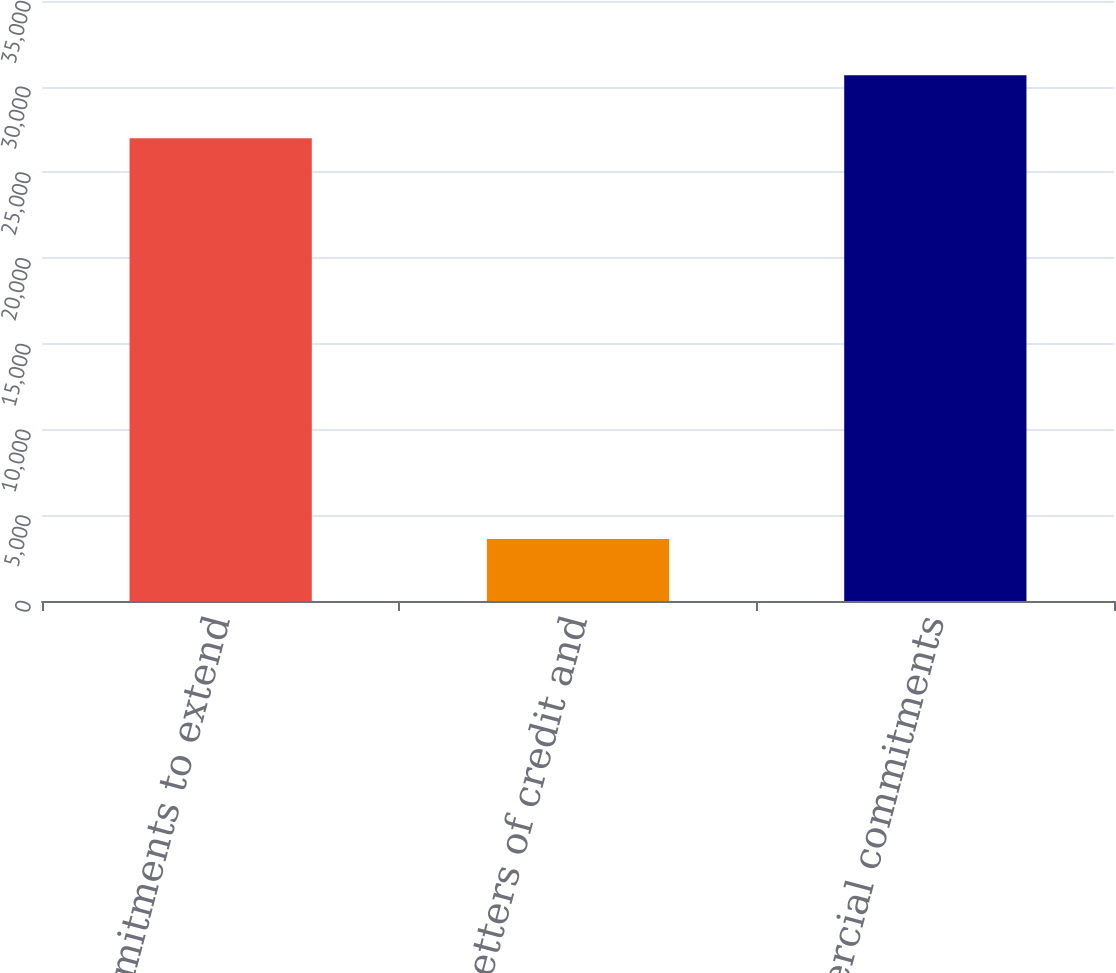Convert chart. <chart><loc_0><loc_0><loc_500><loc_500><bar_chart><fcel>Unused commitments to extend<fcel>Standby letters of credit and<fcel>Total commercial commitments<nl><fcel>26991<fcel>3623<fcel>30662<nl></chart> 